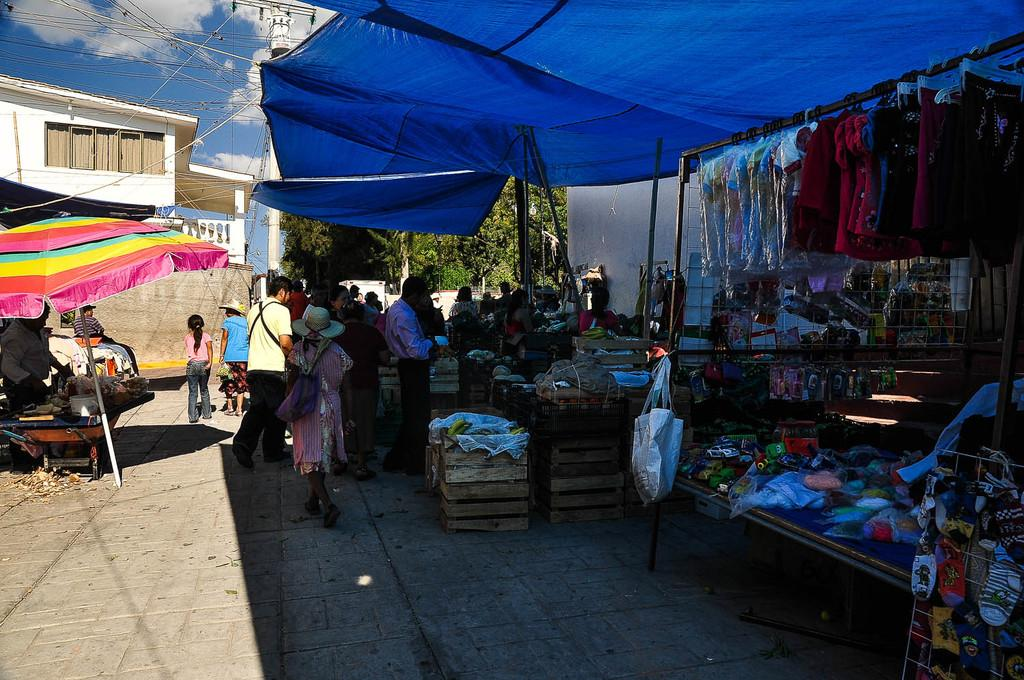What can be seen on the tables in the image? There are items on the tables in the image. What is being used to hang clothes in the image? There is a pole used to hang clothes in the image. What type of structures can be seen in the image? There are houses visible in the image. Who is present in the image? There are people present in the image. What is being used for protection from the elements in the image? There is an umbrella in the image. Where is the gold mine located in the image? There is no gold mine present in the image. What type of man is depicted in the image? There is no specific man depicted in the image; it shows people in general. 